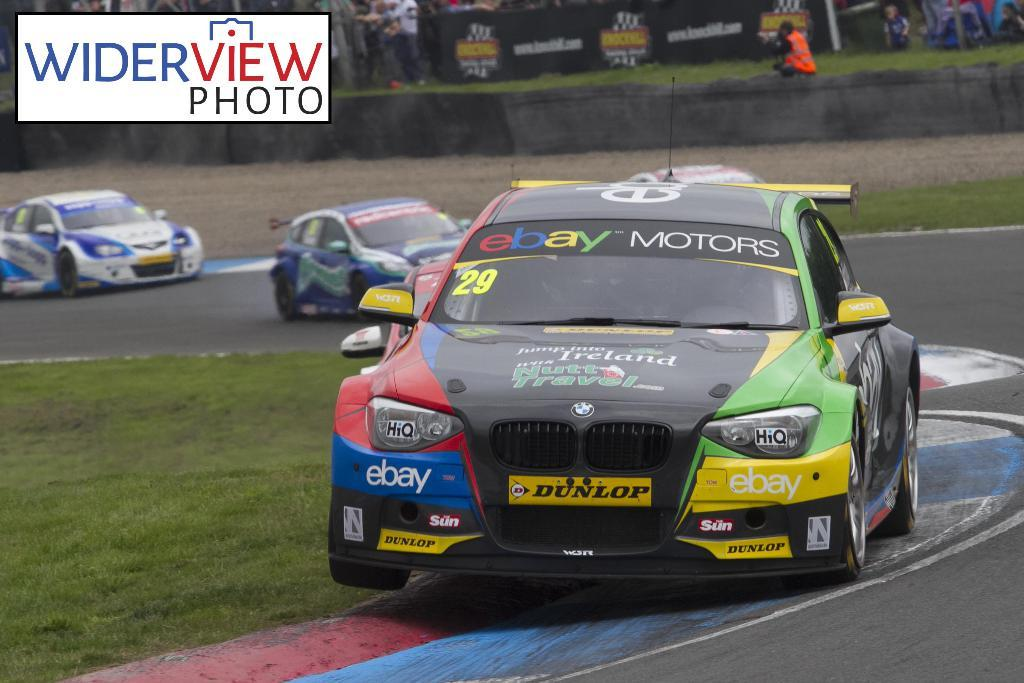What type of vehicles are on the path in the image? There are race cars on the path in the image. What can be seen in the background of the image? There is a group of people, grass, and hoardings in the background of the image. What is the surface on which the race cars are driving? The race cars are on a path in the image. What is the purpose of the hoardings in the background? The purpose of the hoardings is not specified in the image, but they are likely used for advertising or displaying information. What type of toothpaste is being advertised on the race cars in the image? There is no toothpaste being advertised on the race cars in the image. How many wrists are visible in the image? There is no mention of wrists in the image, as it primarily features race cars and background elements. 